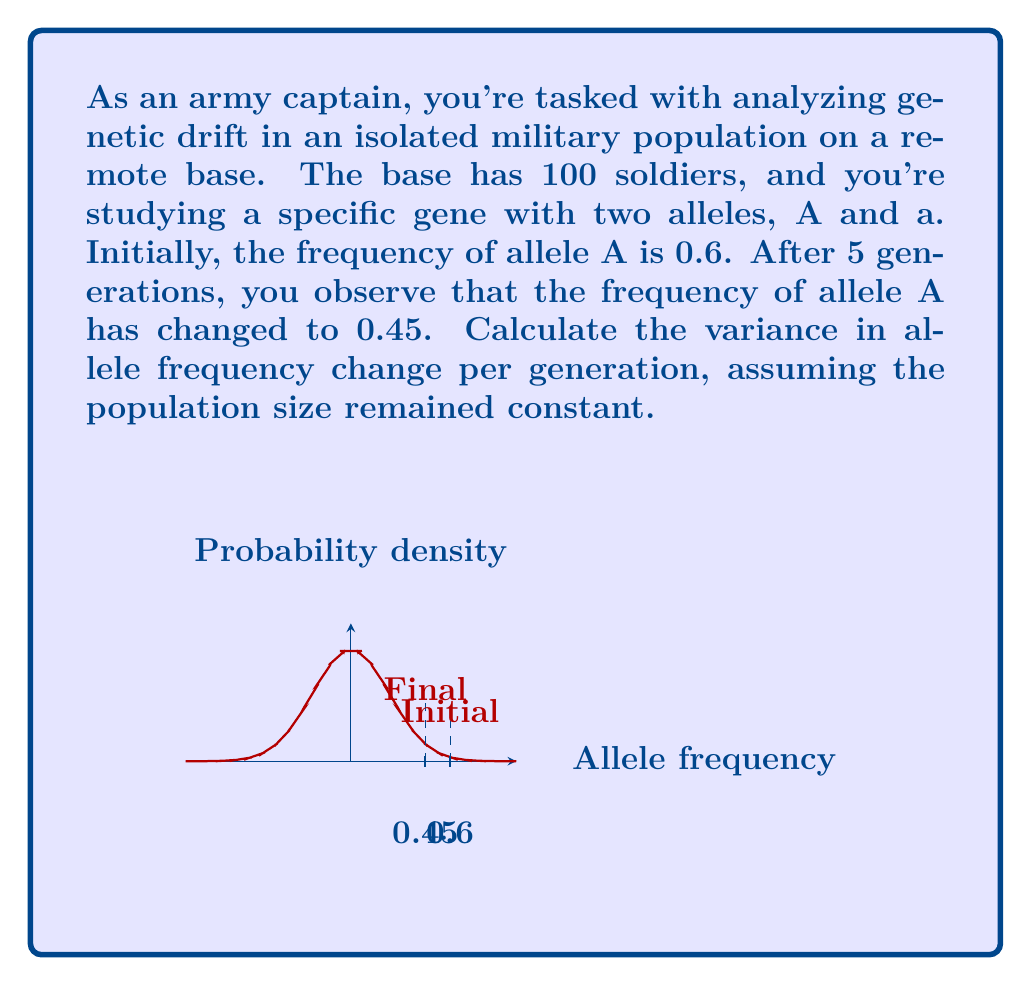Can you answer this question? To solve this problem, we'll use the formula for the variance in allele frequency change due to genetic drift:

$$\text{Var}(\Delta p) = \frac{p(1-p)}{2N_e}$$

Where:
$p$ is the initial allele frequency
$N_e$ is the effective population size
$\Delta p$ is the change in allele frequency per generation

Step 1: Identify the given information
- Initial frequency of allele A ($p_0$) = 0.6
- Final frequency of allele A ($p_5$) = 0.45
- Number of generations ($t$) = 5
- Population size ($N$) = 100

Step 2: Calculate the total change in allele frequency
$$\Delta p_{\text{total}} = p_5 - p_0 = 0.45 - 0.6 = -0.15$$

Step 3: Calculate the average change in allele frequency per generation
$$\Delta p_{\text{avg}} = \frac{\Delta p_{\text{total}}}{t} = \frac{-0.15}{5} = -0.03$$

Step 4: Use the variance formula
Assuming the effective population size ($N_e$) is equal to the actual population size ($N$):

$$\text{Var}(\Delta p) = \frac{p(1-p)}{2N_e} = \frac{0.6(1-0.6)}{2(100)} = \frac{0.24}{200} = 0.0012$$

Therefore, the variance in allele frequency change per generation is 0.0012.
Answer: 0.0012 